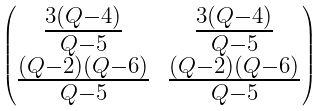<formula> <loc_0><loc_0><loc_500><loc_500>\begin{pmatrix} \frac { 3 ( Q - 4 ) } { Q - 5 } & \frac { 3 ( Q - 4 ) } { Q - 5 } \\ \frac { ( Q - 2 ) ( Q - 6 ) } { Q - 5 } & \frac { ( Q - 2 ) ( Q - 6 ) } { Q - 5 } \end{pmatrix}</formula> 